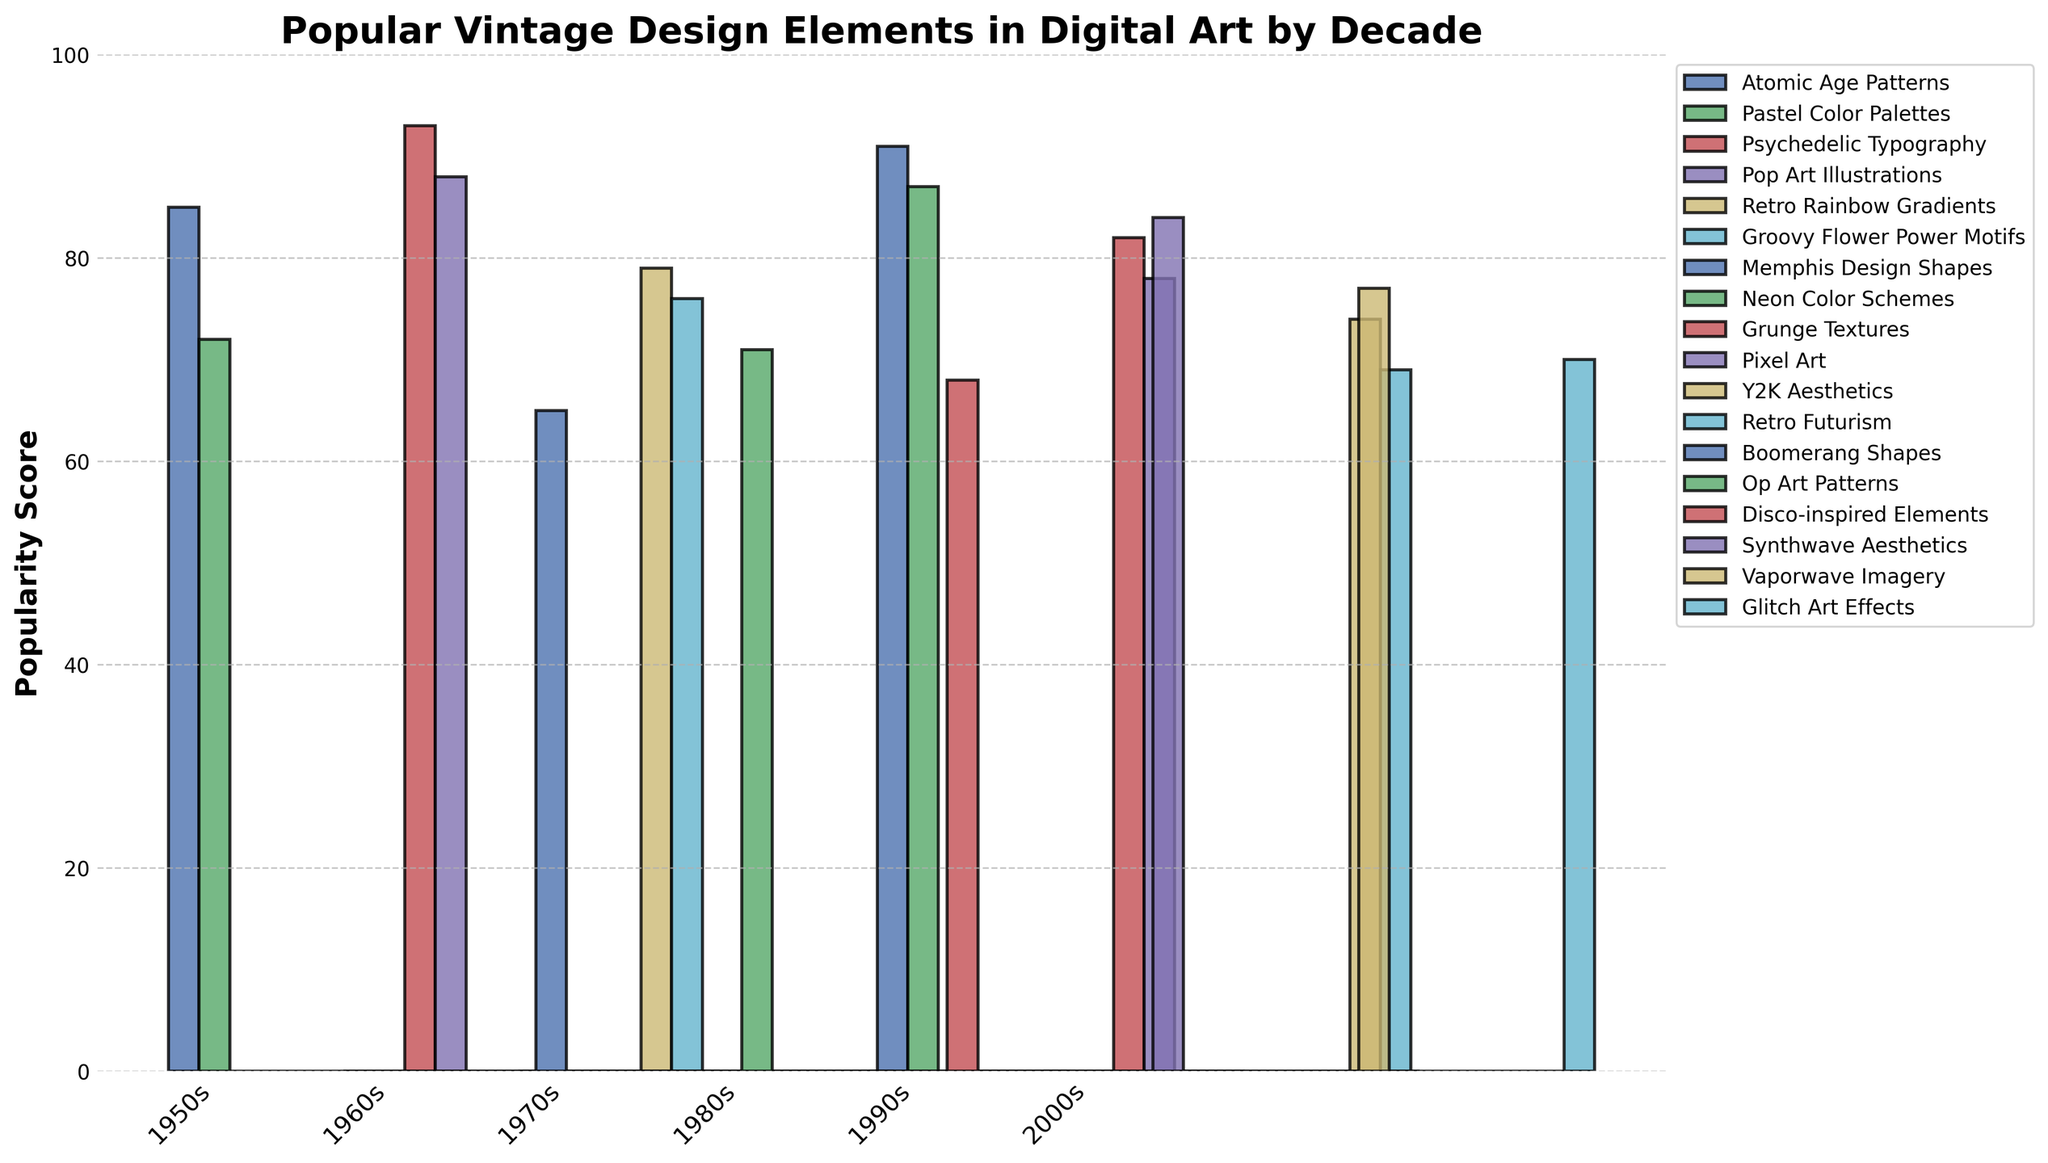Which decade features the highest popularity score for a single design element? The figure shows that the 1960s' Psychedelic Typography has the highest popularity score among all the data points, with a score of 93.
Answer: 1960s Which design element from the 1970s has a higher popularity score, Retro Rainbow Gradients or Groovy Flower Power Motifs? The bar representing Retro Rainbow Gradients is taller than that of Groovy Flower Power Motifs, indicating a higher popularity score. Retro Rainbow Gradients has a score of 79, while Groovy Flower Power Motifs has a score of 76.
Answer: Retro Rainbow Gradients What is the total popularity score for all the design elements from the 1980s? The scores for the 1980s are: Memphis Design Shapes (91), Neon Color Schemes (87), and Synthwave Aesthetics (84). Adding these together: 91 + 87 + 84 = 262.
Answer: 262 How does the popularity score of Grunge Textures compare to that of Pixel Art in the 1990s? The figure shows that the bar for Grunge Textures is taller than that of Pixel Art, indicating a higher popularity score. Grunge Textures has a score of 82, and Pixel Art has a score of 78.
Answer: Grunge Textures Rank the popularity scores of design elements from the 2000s in descending order. Based on the visual heights, the scores in descending order are: Y2K Aesthetics (74), Glitch Art Effects (70), and Retro Futurism (69).
Answer: Y2K Aesthetics, Glitch Art Effects, Retro Futurism What is the average popularity score for design elements from the 1950s? The popularity scores for the 1950s are: Atomic Age Patterns (85), Pastel Color Palettes (72), and Boomerang Shapes (65). The sum is 85 + 72 + 65 = 222. Dividing by 3 gives an average of 222 / 3 ≈ 74.
Answer: 74 Compare the popularity score of Op Art Patterns from the 1960s with that of Vaporwave Imagery from the 1990s. Op Art Patterns for the 1960s has a score of 71, and Vaporwave Imagery from the 1990s has a score of 77. Vaporwave Imagery has a higher score.
Answer: Vaporwave Imagery Which design element has the lowest popularity score in the entire dataset? The figure shows the smallest bar representing Retro Futurism from the 2000s with a score of 69.
Answer: Retro Futurism 